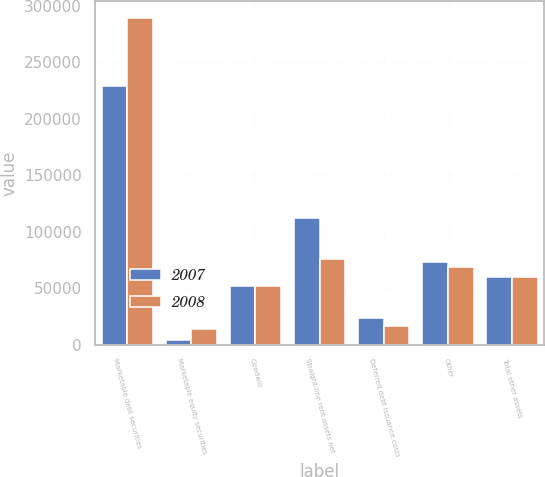Convert chart. <chart><loc_0><loc_0><loc_500><loc_500><stacked_bar_chart><ecel><fcel>Marketable debt securities<fcel>Marketable equity securities<fcel>Goodwill<fcel>Straight-line rent assets net<fcel>Deferred debt issuance costs<fcel>Other<fcel>Total other assets<nl><fcel>2007<fcel>228660<fcel>3845<fcel>51746<fcel>112038<fcel>23512<fcel>73005<fcel>60031<nl><fcel>2008<fcel>289163<fcel>13933<fcel>51746<fcel>76188<fcel>16787<fcel>68316<fcel>60031<nl></chart> 